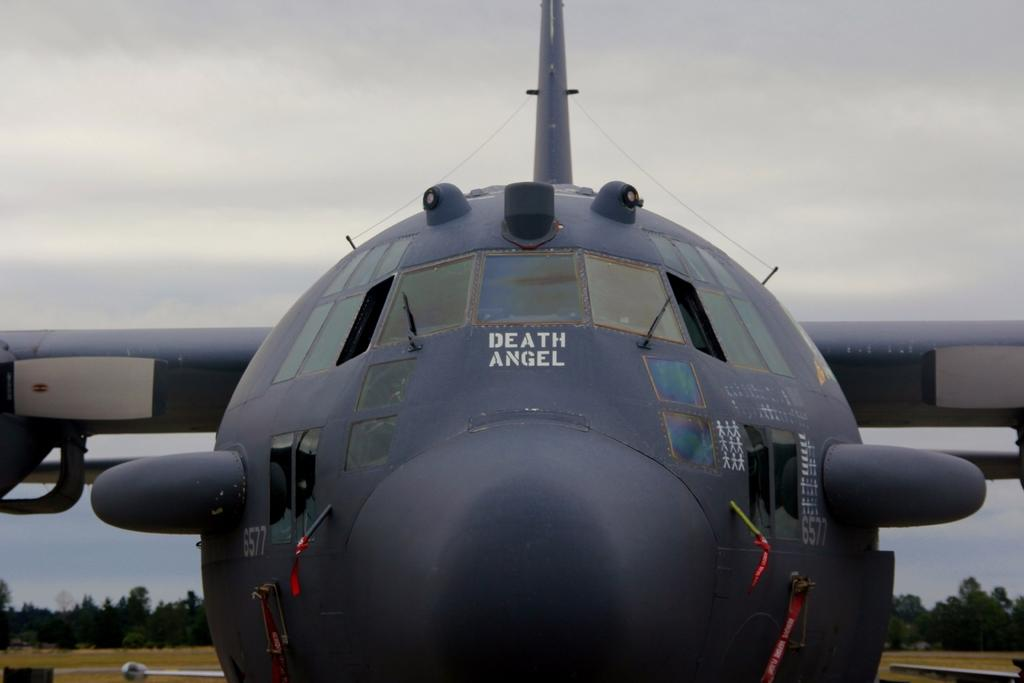<image>
Provide a brief description of the given image. The front of the plane says "Death Angel." 